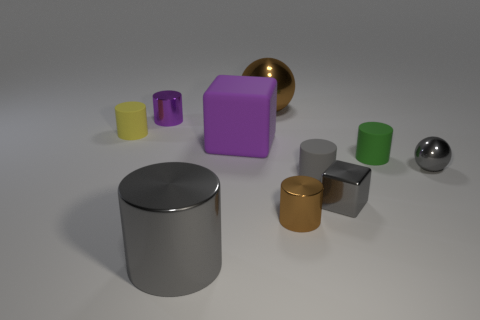What is the size of the purple object that is on the left side of the large purple block?
Your response must be concise. Small. Do the cube behind the tiny gray ball and the sphere that is to the right of the gray shiny block have the same color?
Offer a very short reply. No. What material is the small yellow cylinder behind the tiny block in front of the sphere that is behind the purple metallic cylinder?
Your answer should be very brief. Rubber. Are there any purple rubber things that have the same size as the rubber block?
Keep it short and to the point. No. There is a green cylinder that is the same size as the yellow rubber cylinder; what is its material?
Ensure brevity in your answer.  Rubber. There is a yellow object behind the gray metal sphere; what is its shape?
Your answer should be very brief. Cylinder. Are the gray object that is to the left of the brown cylinder and the sphere behind the big purple matte thing made of the same material?
Offer a terse response. Yes. What number of tiny yellow matte things are the same shape as the tiny gray matte object?
Give a very brief answer. 1. What is the material of the small cylinder that is the same color as the matte cube?
Your response must be concise. Metal. What number of things are gray spheres or objects that are on the right side of the small purple cylinder?
Offer a very short reply. 8. 